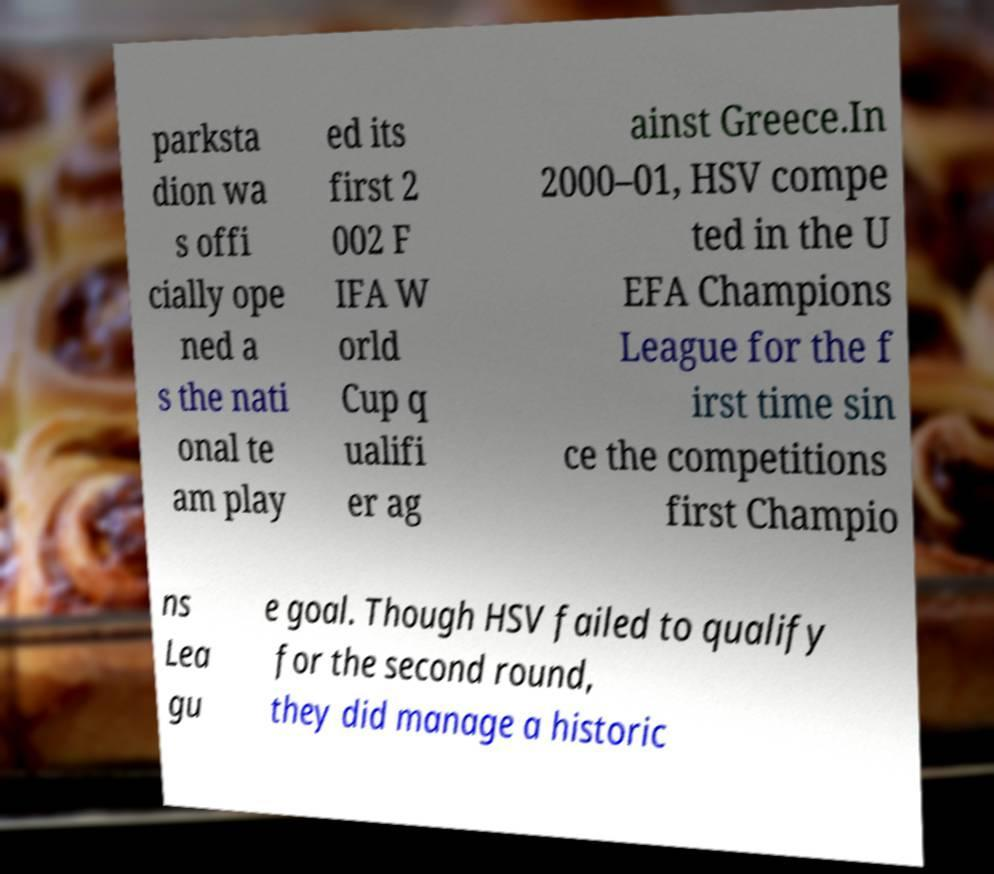I need the written content from this picture converted into text. Can you do that? parksta dion wa s offi cially ope ned a s the nati onal te am play ed its first 2 002 F IFA W orld Cup q ualifi er ag ainst Greece.In 2000–01, HSV compe ted in the U EFA Champions League for the f irst time sin ce the competitions first Champio ns Lea gu e goal. Though HSV failed to qualify for the second round, they did manage a historic 